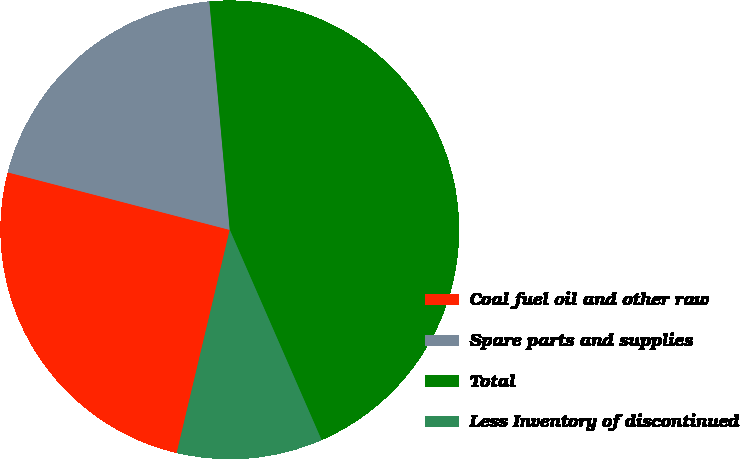Convert chart to OTSL. <chart><loc_0><loc_0><loc_500><loc_500><pie_chart><fcel>Coal fuel oil and other raw<fcel>Spare parts and supplies<fcel>Total<fcel>Less Inventory of discontinued<nl><fcel>25.32%<fcel>19.55%<fcel>44.86%<fcel>10.27%<nl></chart> 